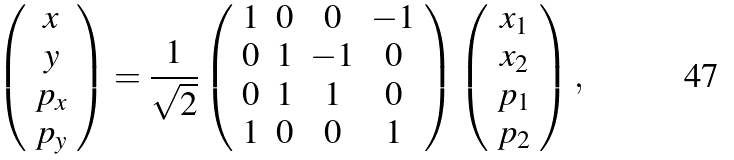<formula> <loc_0><loc_0><loc_500><loc_500>\left ( \begin{array} { c } x \\ y \\ p _ { x } \\ p _ { y } \end{array} \right ) = \frac { 1 } { \sqrt { 2 } } \left ( \begin{array} { c c c c } 1 & 0 & 0 & - 1 \\ 0 & 1 & - 1 & 0 \\ 0 & 1 & 1 & 0 \\ 1 & 0 & 0 & 1 \end{array} \right ) \left ( \begin{array} { c } x _ { 1 } \\ x _ { 2 } \\ p _ { 1 } \\ p _ { 2 } \end{array} \right ) ,</formula> 